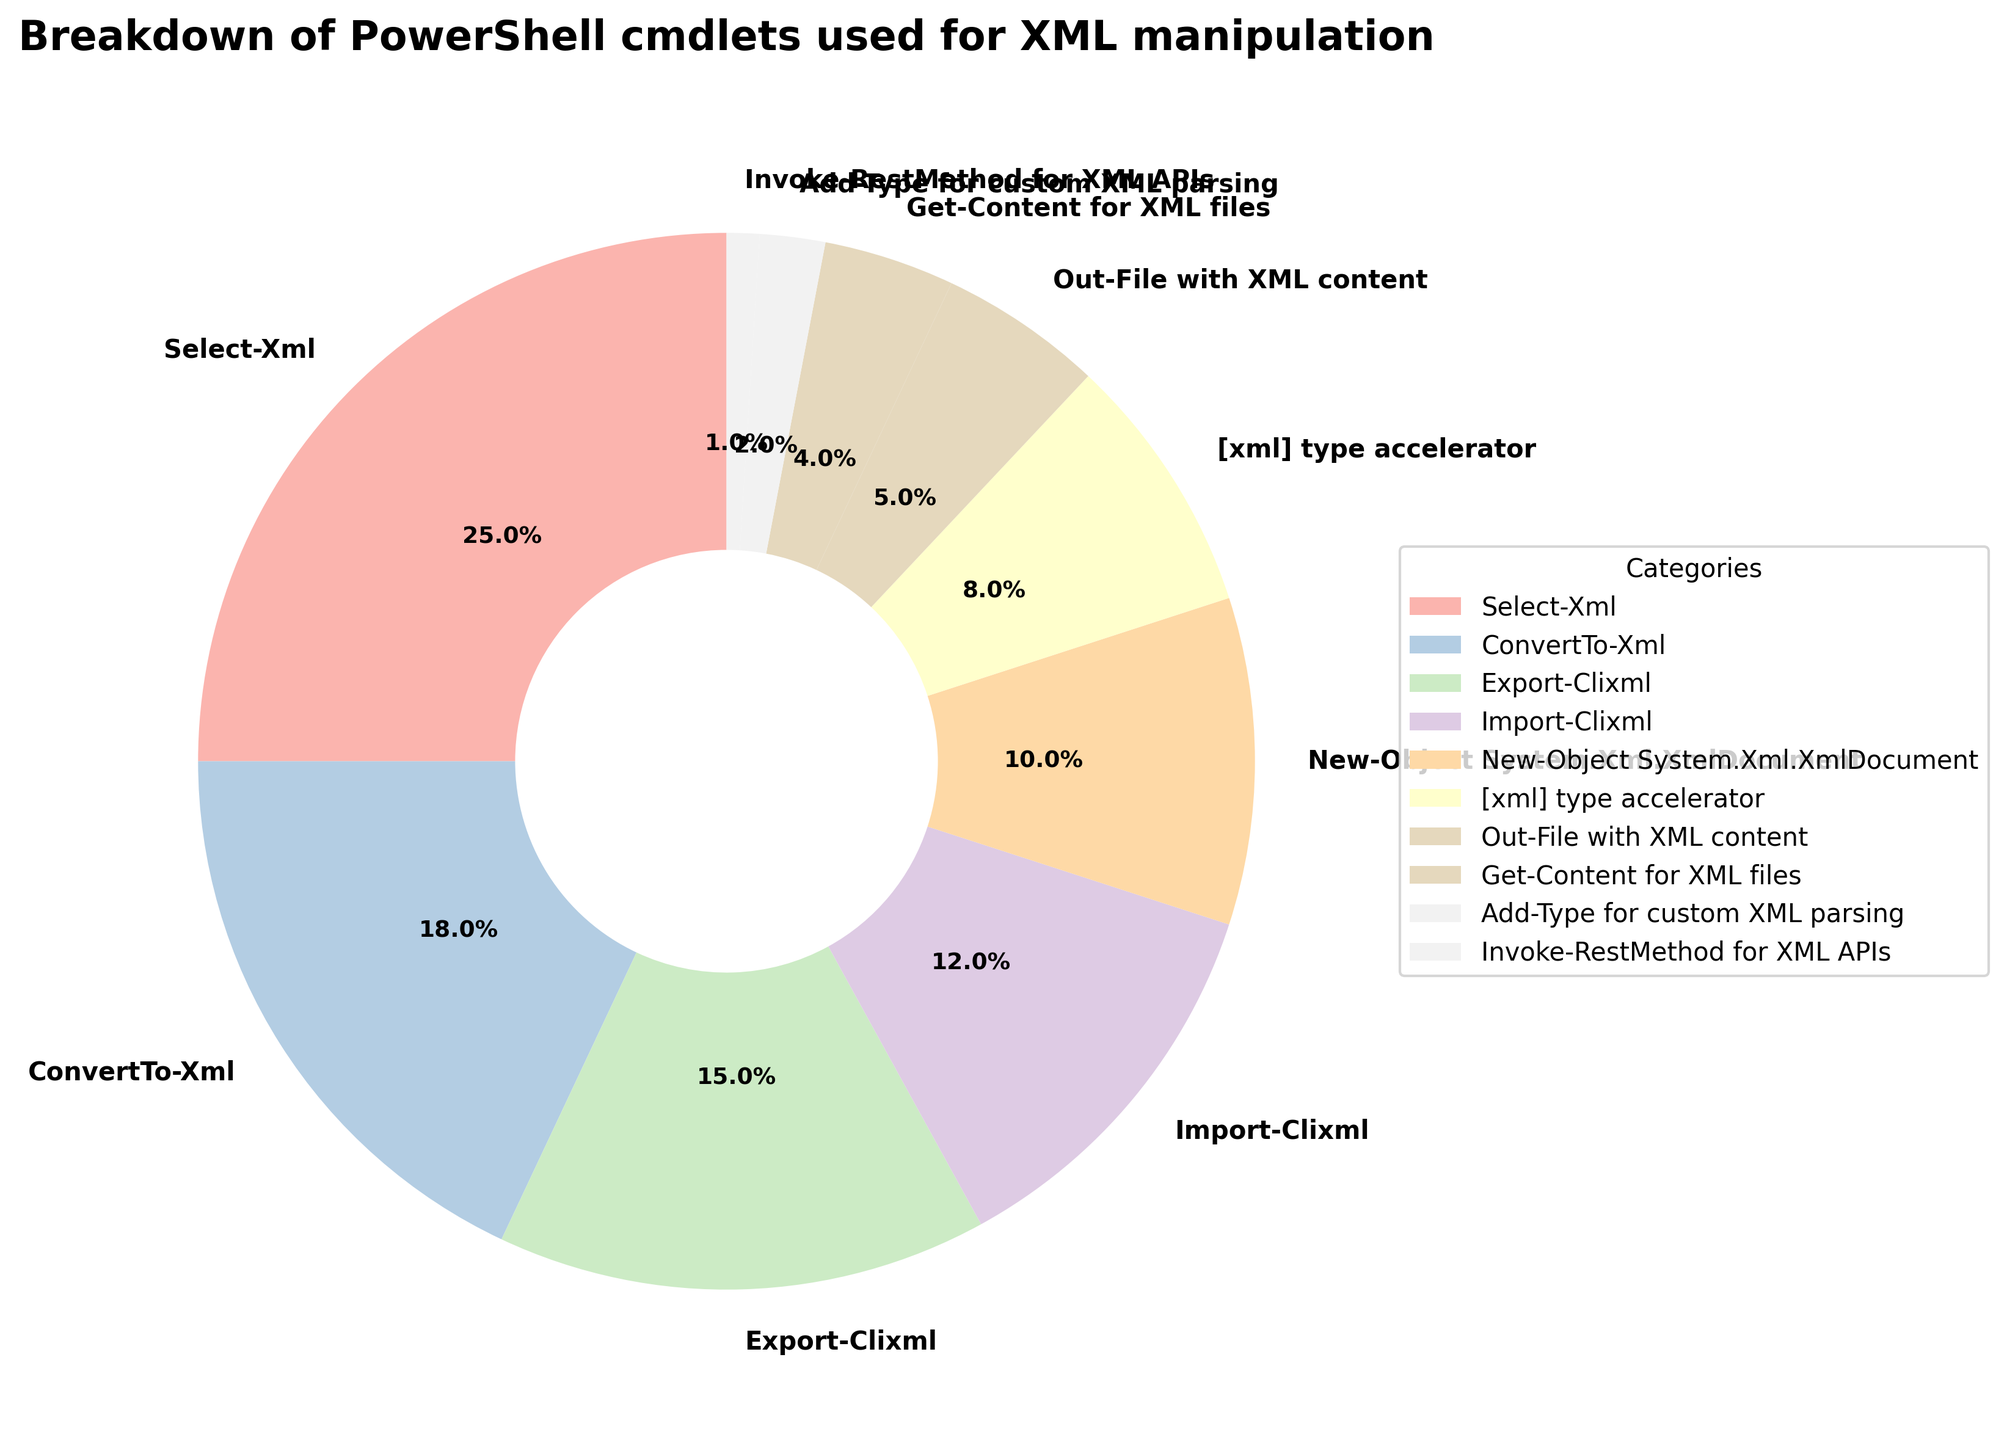Which PowerShell cmdlet is used the most for XML manipulation? The category with the greatest percentage slice in the pie chart is "Select-Xml" with 25%.
Answer: Select-Xml Which PowerShell cmdlet is the least used for XML manipulation? The category with the smallest percentage slice in the pie chart is "Invoke-RestMethod for XML APIs" with 1%.
Answer: Invoke-RestMethod for XML APIs What is the combined usage percentage of 'Export-Clixml' and 'Import-Clixml' cmdlets? The percentage for "Export-Clixml" is 15%, and for "Import-Clixml" it is 12%. Adding these together gives 15% + 12% = 27%.
Answer: 27% How does the usage of 'ConvertTo-Xml' compare to 'New-Object System.Xml.XmlDocument'? "ConvertTo-Xml" has a usage of 18%, while "New-Object System.Xml.XmlDocument" has a usage of 10%. Therefore, "ConvertTo-Xml" is used 8% more than "New-Object System.Xml.XmlDocument".
Answer: 8% more Rank the top three cmdlets used for XML manipulation. The top three cmdlets by percentage are "Select-Xml" (25%), "ConvertTo-Xml" (18%), and "Export-Clixml" (15%).
Answer: Select-Xml, ConvertTo-Xml, Export-Clixml Which section of the pie chart is represented by a pale color (considering Pastel1 color palette)? In a pastel color palette, typically lighter colors are used. The pale color segment with a noticeable label belongs to "Invoke-RestMethod for XML APIs", which is the smallest segment (1%).
Answer: Invoke-RestMethod for XML APIs What is the difference in usage percentage between 'Out-File with XML content' and '[xml] type accelerator' cmdlets? "Out-File with XML content" is used 5%, whereas "[xml] type accelerator" is used 8%. The difference is
Answer: 3% Which cmdlet categories collectively make up more than half of the total usage? Adding up the top categories: "Select-Xml" (25%), "ConvertTo-Xml" (18%), and "Export-Clixml" (15%) results in a total of 25% + 18% + 15% = 58%, which is more than half.
Answer: Select-Xml, ConvertTo-Xml, Export-Clixml Is 'Get-Content for XML files' used more often or less often than 'Out-File with XML content'? "Get-Content for XML files" is used 4%, which is 1% less than "Out-File with XML content" at 5%.
Answer: Less often Which cmdlets have a combined usage that is closest to 20%? The combined usage of "[xml] type accelerator" (8%) and "New-Object System.Xml.XmlDocument" (10%) is 18%, which is closest to 20%.
Answer: [xml] type accelerator, New-Object System.Xml.XmlDocument 